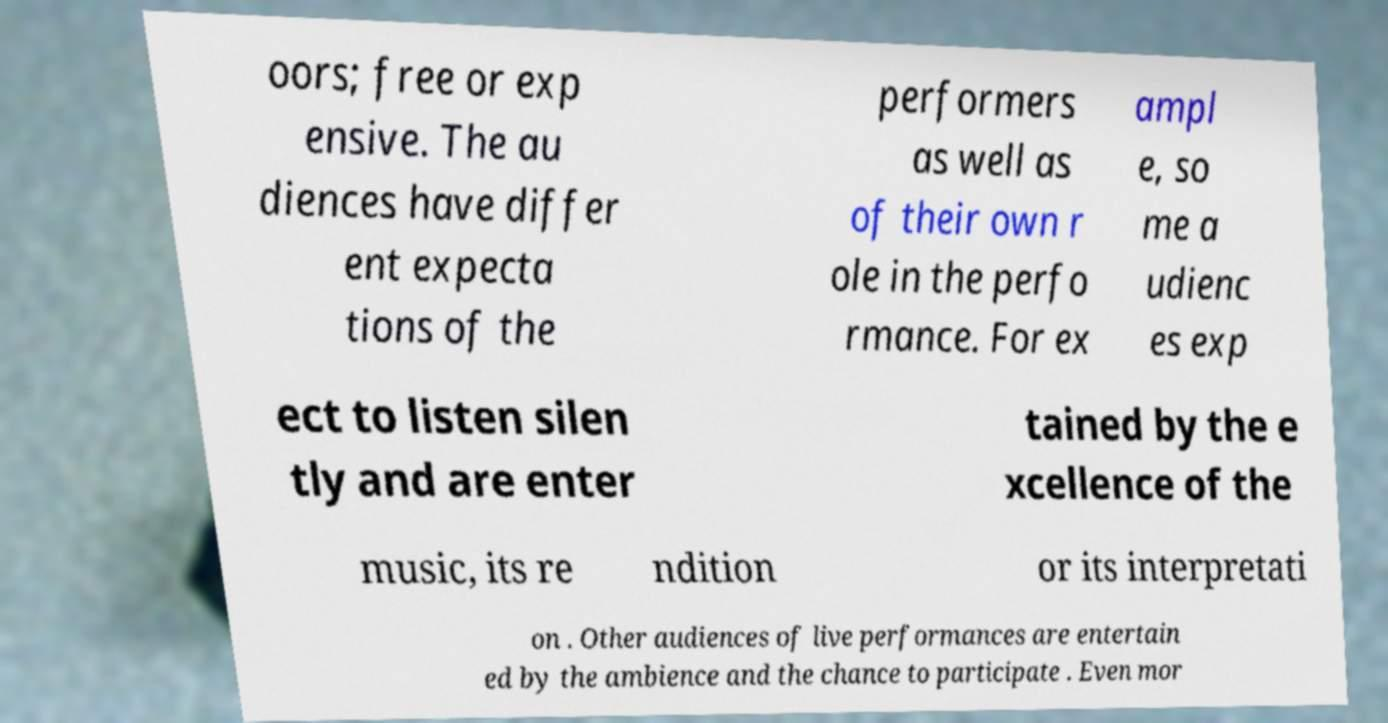Could you extract and type out the text from this image? oors; free or exp ensive. The au diences have differ ent expecta tions of the performers as well as of their own r ole in the perfo rmance. For ex ampl e, so me a udienc es exp ect to listen silen tly and are enter tained by the e xcellence of the music, its re ndition or its interpretati on . Other audiences of live performances are entertain ed by the ambience and the chance to participate . Even mor 